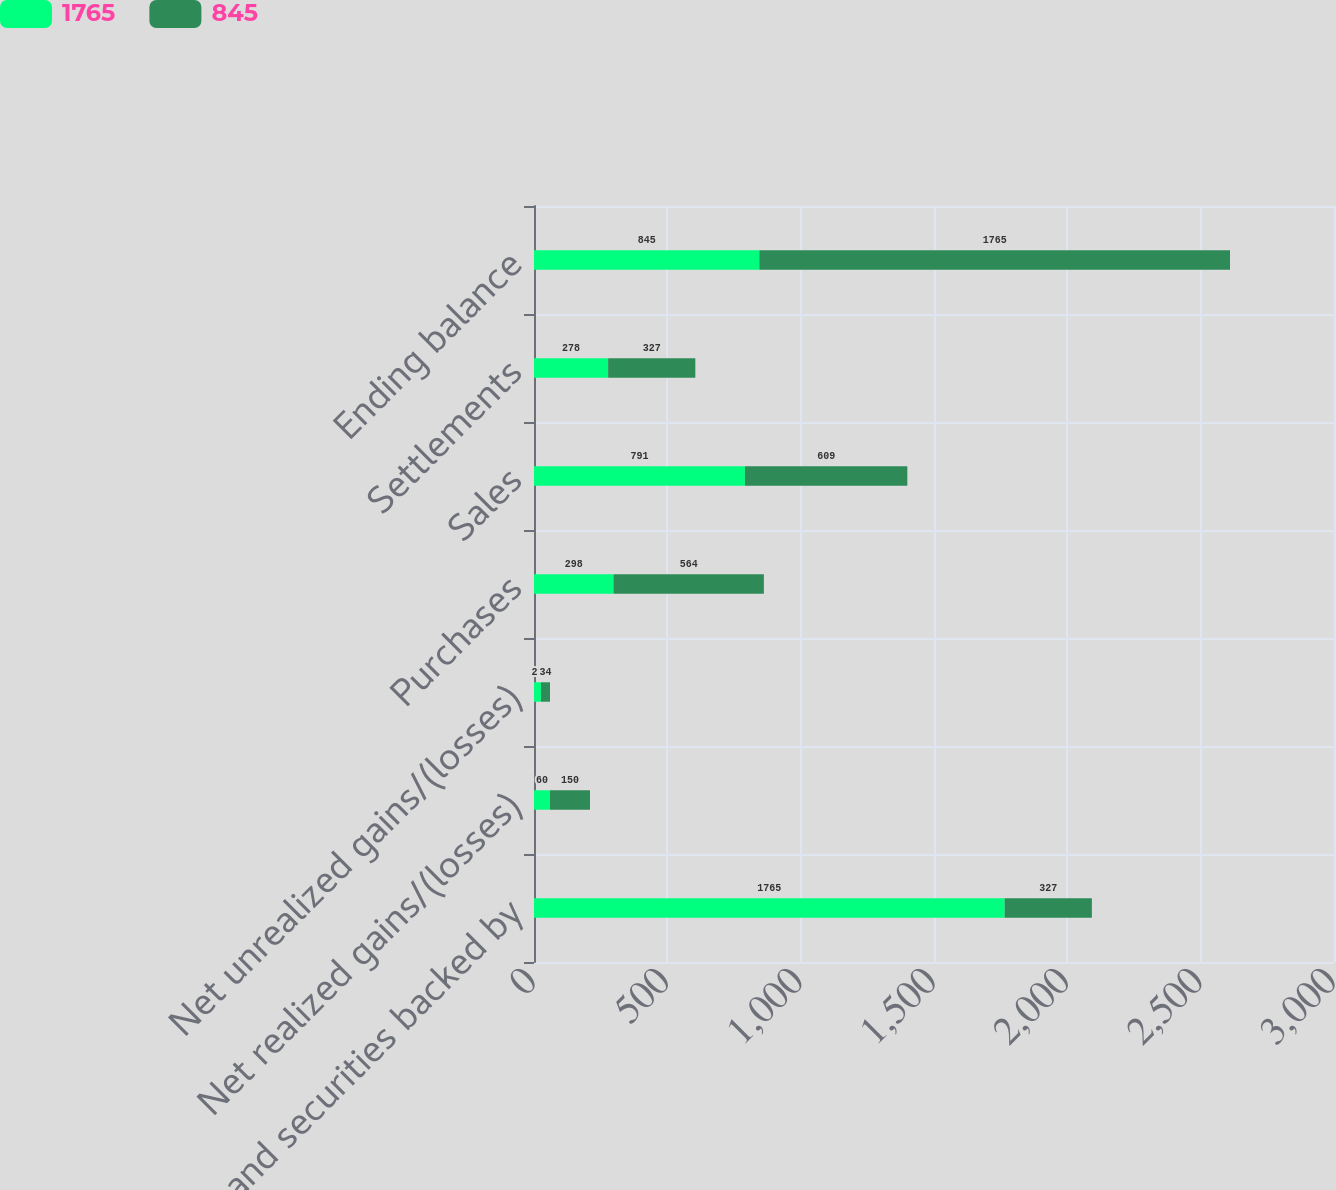Convert chart to OTSL. <chart><loc_0><loc_0><loc_500><loc_500><stacked_bar_chart><ecel><fcel>Loans and securities backed by<fcel>Net realized gains/(losses)<fcel>Net unrealized gains/(losses)<fcel>Purchases<fcel>Sales<fcel>Settlements<fcel>Ending balance<nl><fcel>1765<fcel>1765<fcel>60<fcel>26<fcel>298<fcel>791<fcel>278<fcel>845<nl><fcel>845<fcel>327<fcel>150<fcel>34<fcel>564<fcel>609<fcel>327<fcel>1765<nl></chart> 